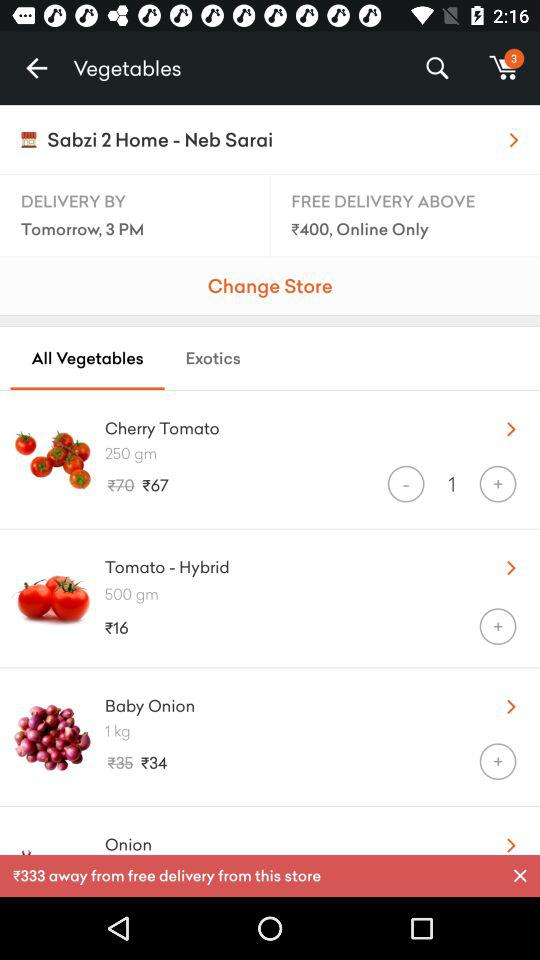What is the weight of "Tomato - Hybrid"? The weight of "Tomato - Hybrid" is 500 grams. 